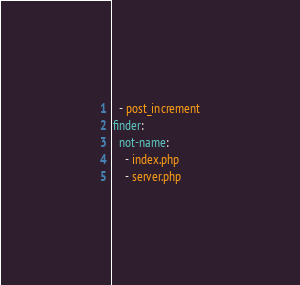<code> <loc_0><loc_0><loc_500><loc_500><_YAML_>  - post_increment
finder:
  not-name:
    - index.php
    - server.php
</code> 